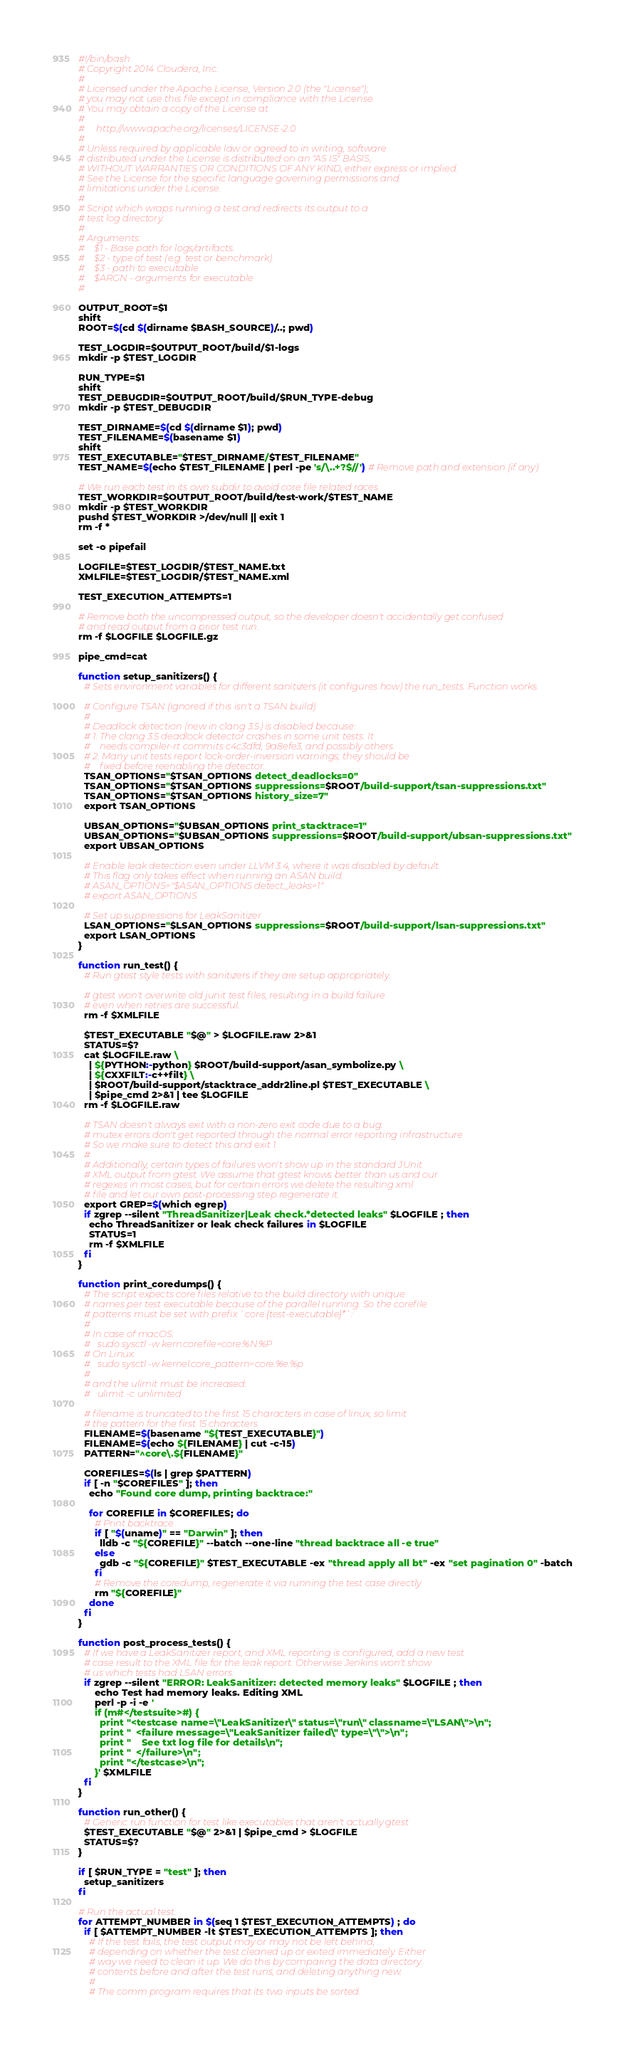Convert code to text. <code><loc_0><loc_0><loc_500><loc_500><_Bash_>#!/bin/bash
# Copyright 2014 Cloudera, Inc.
#
# Licensed under the Apache License, Version 2.0 (the "License");
# you may not use this file except in compliance with the License.
# You may obtain a copy of the License at
#
#     http://www.apache.org/licenses/LICENSE-2.0
#
# Unless required by applicable law or agreed to in writing, software
# distributed under the License is distributed on an "AS IS" BASIS,
# WITHOUT WARRANTIES OR CONDITIONS OF ANY KIND, either express or implied.
# See the License for the specific language governing permissions and
# limitations under the License.
#
# Script which wraps running a test and redirects its output to a
# test log directory.
#
# Arguments:
#    $1 - Base path for logs/artifacts.
#    $2 - type of test (e.g. test or benchmark)
#    $3 - path to executable
#    $ARGN - arguments for executable
#

OUTPUT_ROOT=$1
shift
ROOT=$(cd $(dirname $BASH_SOURCE)/..; pwd)

TEST_LOGDIR=$OUTPUT_ROOT/build/$1-logs
mkdir -p $TEST_LOGDIR

RUN_TYPE=$1
shift
TEST_DEBUGDIR=$OUTPUT_ROOT/build/$RUN_TYPE-debug
mkdir -p $TEST_DEBUGDIR

TEST_DIRNAME=$(cd $(dirname $1); pwd)
TEST_FILENAME=$(basename $1)
shift
TEST_EXECUTABLE="$TEST_DIRNAME/$TEST_FILENAME"
TEST_NAME=$(echo $TEST_FILENAME | perl -pe 's/\..+?$//') # Remove path and extension (if any).

# We run each test in its own subdir to avoid core file related races.
TEST_WORKDIR=$OUTPUT_ROOT/build/test-work/$TEST_NAME
mkdir -p $TEST_WORKDIR
pushd $TEST_WORKDIR >/dev/null || exit 1
rm -f *

set -o pipefail

LOGFILE=$TEST_LOGDIR/$TEST_NAME.txt
XMLFILE=$TEST_LOGDIR/$TEST_NAME.xml

TEST_EXECUTION_ATTEMPTS=1

# Remove both the uncompressed output, so the developer doesn't accidentally get confused
# and read output from a prior test run.
rm -f $LOGFILE $LOGFILE.gz

pipe_cmd=cat

function setup_sanitizers() {
  # Sets environment variables for different sanitizers (it configures how) the run_tests. Function works.

  # Configure TSAN (ignored if this isn't a TSAN build).
  #
  # Deadlock detection (new in clang 3.5) is disabled because:
  # 1. The clang 3.5 deadlock detector crashes in some unit tests. It
  #    needs compiler-rt commits c4c3dfd, 9a8efe3, and possibly others.
  # 2. Many unit tests report lock-order-inversion warnings; they should be
  #    fixed before reenabling the detector.
  TSAN_OPTIONS="$TSAN_OPTIONS detect_deadlocks=0"
  TSAN_OPTIONS="$TSAN_OPTIONS suppressions=$ROOT/build-support/tsan-suppressions.txt"
  TSAN_OPTIONS="$TSAN_OPTIONS history_size=7"
  export TSAN_OPTIONS

  UBSAN_OPTIONS="$UBSAN_OPTIONS print_stacktrace=1"
  UBSAN_OPTIONS="$UBSAN_OPTIONS suppressions=$ROOT/build-support/ubsan-suppressions.txt"
  export UBSAN_OPTIONS

  # Enable leak detection even under LLVM 3.4, where it was disabled by default.
  # This flag only takes effect when running an ASAN build.
  # ASAN_OPTIONS="$ASAN_OPTIONS detect_leaks=1"
  # export ASAN_OPTIONS

  # Set up suppressions for LeakSanitizer
  LSAN_OPTIONS="$LSAN_OPTIONS suppressions=$ROOT/build-support/lsan-suppressions.txt"
  export LSAN_OPTIONS
}

function run_test() {
  # Run gtest style tests with sanitizers if they are setup appropriately.

  # gtest won't overwrite old junit test files, resulting in a build failure
  # even when retries are successful.
  rm -f $XMLFILE

  $TEST_EXECUTABLE "$@" > $LOGFILE.raw 2>&1
  STATUS=$?
  cat $LOGFILE.raw \
    | ${PYTHON:-python} $ROOT/build-support/asan_symbolize.py \
    | ${CXXFILT:-c++filt} \
    | $ROOT/build-support/stacktrace_addr2line.pl $TEST_EXECUTABLE \
    | $pipe_cmd 2>&1 | tee $LOGFILE
  rm -f $LOGFILE.raw

  # TSAN doesn't always exit with a non-zero exit code due to a bug:
  # mutex errors don't get reported through the normal error reporting infrastructure.
  # So we make sure to detect this and exit 1.
  #
  # Additionally, certain types of failures won't show up in the standard JUnit
  # XML output from gtest. We assume that gtest knows better than us and our
  # regexes in most cases, but for certain errors we delete the resulting xml
  # file and let our own post-processing step regenerate it.
  export GREP=$(which egrep)
  if zgrep --silent "ThreadSanitizer|Leak check.*detected leaks" $LOGFILE ; then
    echo ThreadSanitizer or leak check failures in $LOGFILE
    STATUS=1
    rm -f $XMLFILE
  fi
}

function print_coredumps() {
  # The script expects core files relative to the build directory with unique
  # names per test executable because of the parallel running. So the corefile
  # patterns must be set with prefix `core.{test-executable}*`:
  #
  # In case of macOS:
  #   sudo sysctl -w kern.corefile=core.%N.%P
  # On Linux:
  #   sudo sysctl -w kernel.core_pattern=core.%e.%p
  #
  # and the ulimit must be increased:
  #   ulimit -c unlimited

  # filename is truncated to the first 15 characters in case of linux, so limit
  # the pattern for the first 15 characters
  FILENAME=$(basename "${TEST_EXECUTABLE}")
  FILENAME=$(echo ${FILENAME} | cut -c-15)
  PATTERN="^core\.${FILENAME}"

  COREFILES=$(ls | grep $PATTERN)
  if [ -n "$COREFILES" ]; then
    echo "Found core dump, printing backtrace:"

    for COREFILE in $COREFILES; do
      # Print backtrace
      if [ "$(uname)" == "Darwin" ]; then
        lldb -c "${COREFILE}" --batch --one-line "thread backtrace all -e true"
      else
        gdb -c "${COREFILE}" $TEST_EXECUTABLE -ex "thread apply all bt" -ex "set pagination 0" -batch
      fi
      # Remove the coredump, regenerate it via running the test case directly
      rm "${COREFILE}"
    done
  fi
}

function post_process_tests() {
  # If we have a LeakSanitizer report, and XML reporting is configured, add a new test
  # case result to the XML file for the leak report. Otherwise Jenkins won't show
  # us which tests had LSAN errors.
  if zgrep --silent "ERROR: LeakSanitizer: detected memory leaks" $LOGFILE ; then
      echo Test had memory leaks. Editing XML
      perl -p -i -e '
      if (m#</testsuite>#) {
        print "<testcase name=\"LeakSanitizer\" status=\"run\" classname=\"LSAN\">\n";
        print "  <failure message=\"LeakSanitizer failed\" type=\"\">\n";
        print "    See txt log file for details\n";
        print "  </failure>\n";
        print "</testcase>\n";
      }' $XMLFILE
  fi
}

function run_other() {
  # Generic run function for test like executables that aren't actually gtest
  $TEST_EXECUTABLE "$@" 2>&1 | $pipe_cmd > $LOGFILE
  STATUS=$?
}

if [ $RUN_TYPE = "test" ]; then
  setup_sanitizers
fi

# Run the actual test.
for ATTEMPT_NUMBER in $(seq 1 $TEST_EXECUTION_ATTEMPTS) ; do
  if [ $ATTEMPT_NUMBER -lt $TEST_EXECUTION_ATTEMPTS ]; then
    # If the test fails, the test output may or may not be left behind,
    # depending on whether the test cleaned up or exited immediately. Either
    # way we need to clean it up. We do this by comparing the data directory
    # contents before and after the test runs, and deleting anything new.
    #
    # The comm program requires that its two inputs be sorted.</code> 